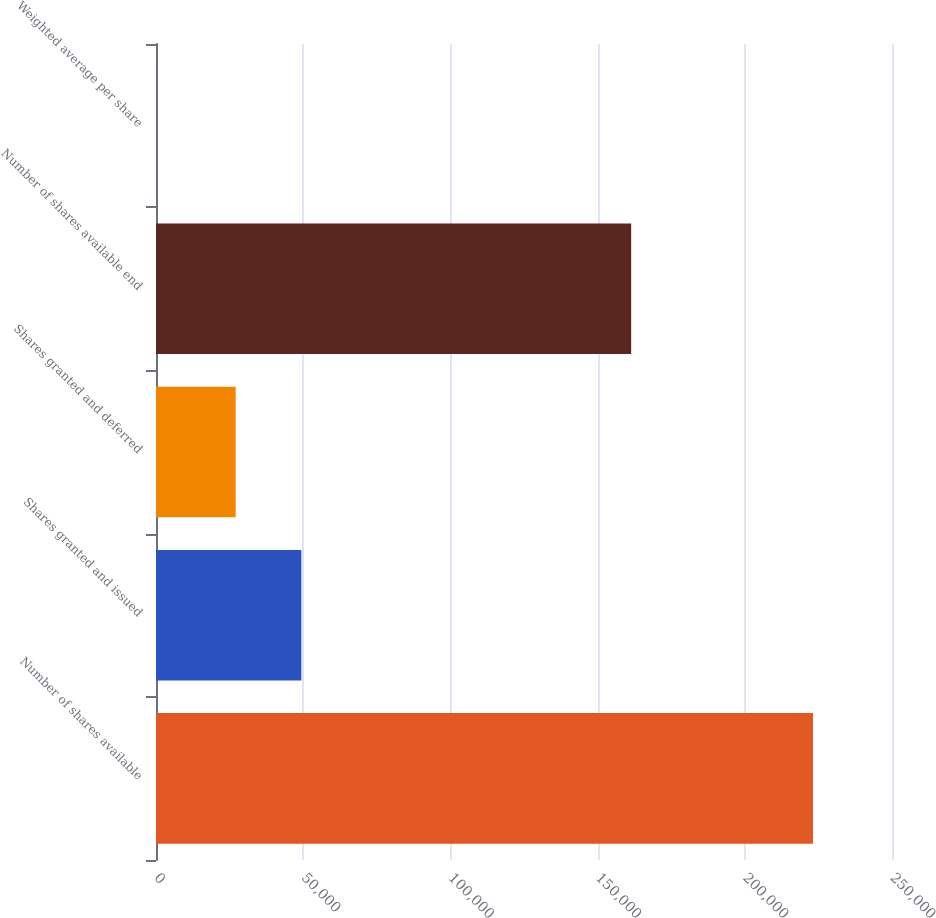<chart> <loc_0><loc_0><loc_500><loc_500><bar_chart><fcel>Number of shares available<fcel>Shares granted and issued<fcel>Shares granted and deferred<fcel>Number of shares available end<fcel>Weighted average per share<nl><fcel>223156<fcel>49374<fcel>27060<fcel>161399<fcel>16.26<nl></chart> 